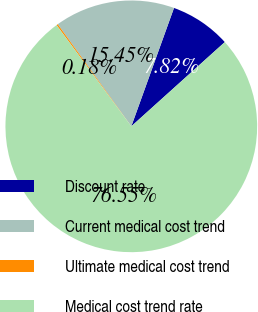Convert chart. <chart><loc_0><loc_0><loc_500><loc_500><pie_chart><fcel>Discount rate<fcel>Current medical cost trend<fcel>Ultimate medical cost trend<fcel>Medical cost trend rate<nl><fcel>7.82%<fcel>15.45%<fcel>0.18%<fcel>76.55%<nl></chart> 